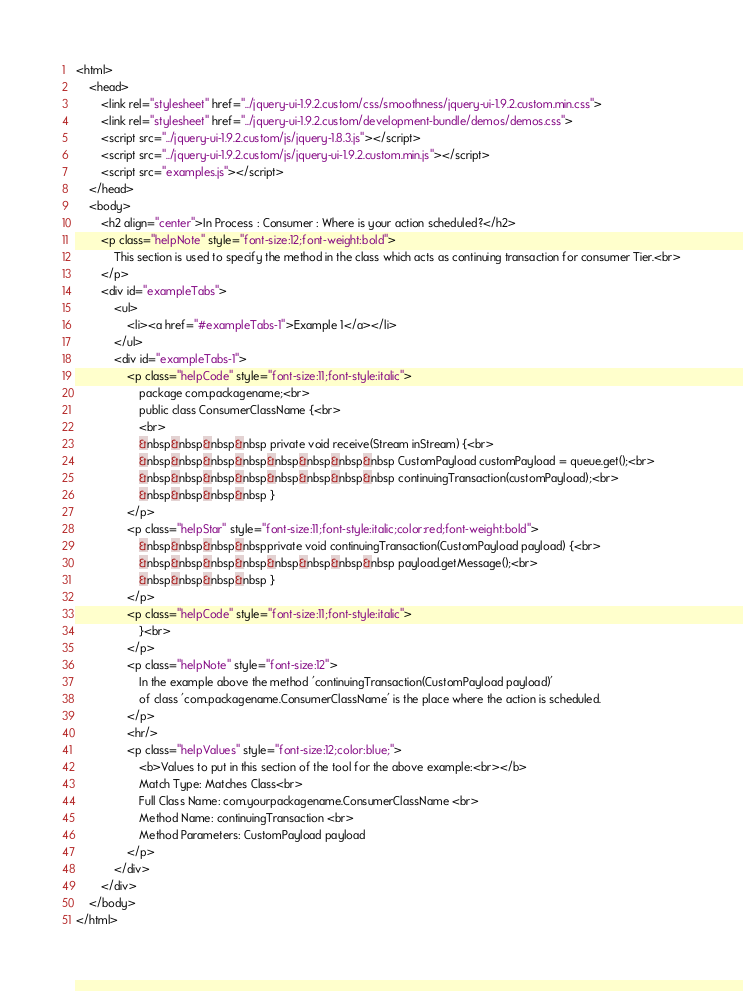<code> <loc_0><loc_0><loc_500><loc_500><_HTML_><html>
    <head>
        <link rel="stylesheet" href="../jquery-ui-1.9.2.custom/css/smoothness/jquery-ui-1.9.2.custom.min.css">
        <link rel="stylesheet" href="../jquery-ui-1.9.2.custom/development-bundle/demos/demos.css">
        <script src="../jquery-ui-1.9.2.custom/js/jquery-1.8.3.js"></script>
        <script src="../jquery-ui-1.9.2.custom/js/jquery-ui-1.9.2.custom.min.js"></script>
        <script src="examples.js"></script>
    </head>
    <body>
        <h2 align="center">In Process : Consumer : Where is your action scheduled?</h2>
        <p class="helpNote" style="font-size:12;font-weight:bold">
            This section is used to specify the method in the class which acts as continuing transaction for consumer Tier.<br>
        </p>
        <div id="exampleTabs">
            <ul>
                <li><a href="#exampleTabs-1">Example 1</a></li>
            </ul>
            <div id="exampleTabs-1">
                <p class="helpCode" style="font-size:11;font-style:italic">
                    package com.packagename;<br>
                    public class ConsumerClassName {<br>
                    <br>
                    &nbsp&nbsp&nbsp&nbsp private void receive(Stream inStream) {<br>
                    &nbsp&nbsp&nbsp&nbsp&nbsp&nbsp&nbsp&nbsp CustomPayload customPayload = queue.get();<br>
                    &nbsp&nbsp&nbsp&nbsp&nbsp&nbsp&nbsp&nbsp continuingTransaction(customPayload);<br>
                    &nbsp&nbsp&nbsp&nbsp }
                </p>
                <p class="helpStar" style="font-size:11;font-style:italic;color:red;font-weight:bold">
                    &nbsp&nbsp&nbsp&nbspprivate void continuingTransaction(CustomPayload payload) {<br>
                    &nbsp&nbsp&nbsp&nbsp&nbsp&nbsp&nbsp&nbsp payload.getMessage();<br>
                    &nbsp&nbsp&nbsp&nbsp }
                </p>
                <p class="helpCode" style="font-size:11;font-style:italic">
                    }<br>
                </p>
                <p class="helpNote" style="font-size:12">
                    In the example above the method 'continuingTransaction(CustomPayload payload)'
                    of class 'com.packagename.ConsumerClassName' is the place where the action is scheduled.
                </p>
                <hr/>
                <p class="helpValues" style="font-size:12;color:blue;">
                    <b>Values to put in this section of the tool for the above example:<br></b>
                    Match Type: Matches Class<br>
                    Full Class Name: com.yourpackagename.ConsumerClassName <br>
                    Method Name: continuingTransaction <br>
                    Method Parameters: CustomPayload payload
                </p>
            </div>
        </div>
    </body>
</html></code> 